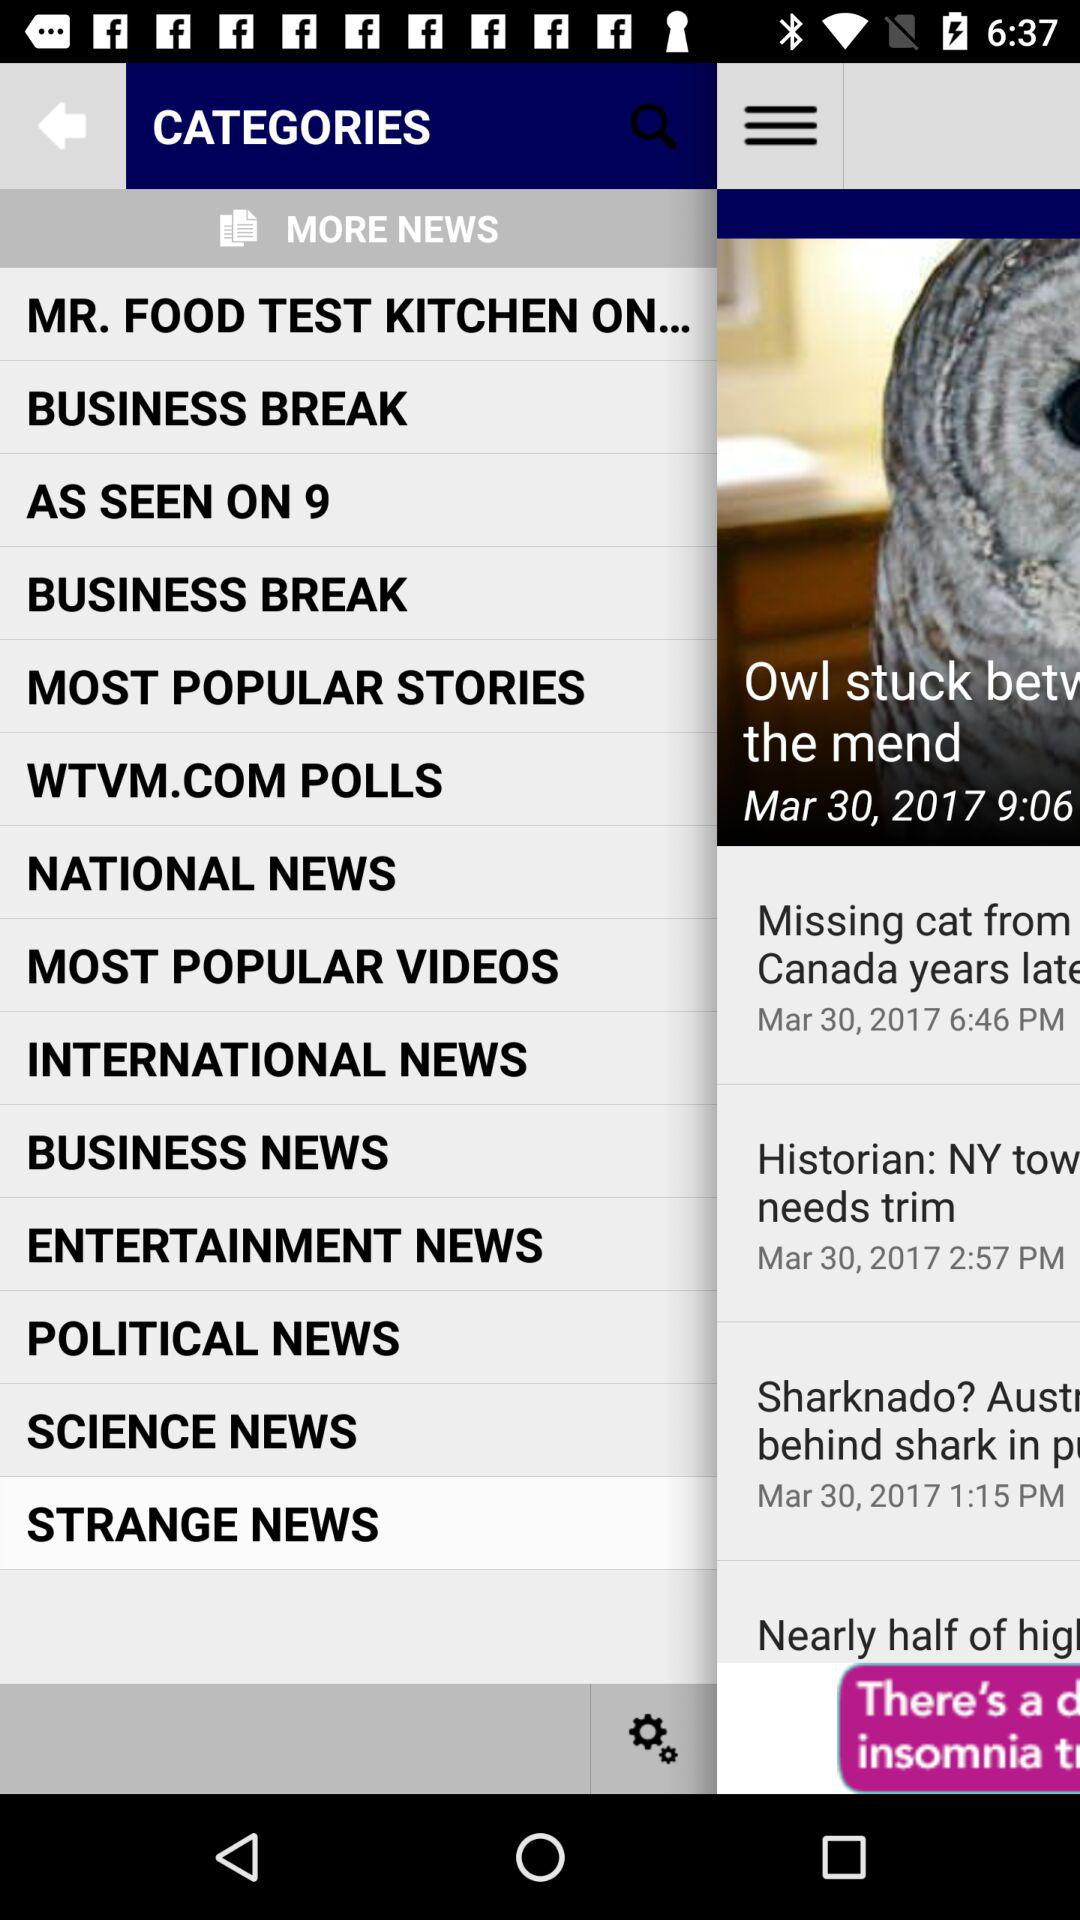What is the selected news category? The selected news category is "STRANGE NEWS". 